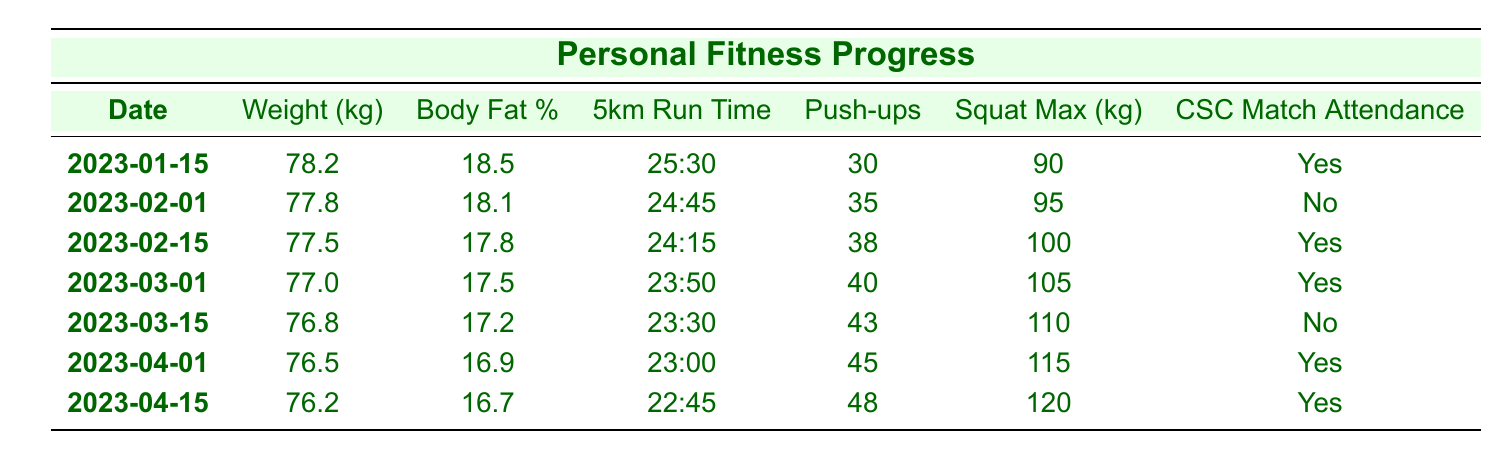What was the lowest recorded weight in the table? The lowest recorded weight can be found by comparing the "Weight (kg)" values across all the rows. The values are 78.2, 77.8, 77.5, 77.0, 76.8, 76.5, and 76.2. The lowest among these is 76.2 kg, which corresponds to the date 2023-04-15.
Answer: 76.2 kg On how many occasions did the attendance for CSC matches occur? To determine the total attendance at CSC matches, count the "Yes" entries in the "CSC Match Attendance" column. There are 5 rows with "Yes" (2023-01-15, 2023-02-15, 2023-03-01, 2023-04-01, and 2023-04-15).
Answer: 5 What is the average body fat percentage from January to April? To find the average body fat percentage, we sum the body fat percentages (18.5, 18.1, 17.8, 17.5, 17.2, and 16.9) and divide by the number of data points (6). The sum is 106.0. Therefore, the average is 106.0/6 ≈ 17.67%.
Answer: 17.67% Did body fat percentage decrease over time? Comparing the body fat percentages from each date shows a consistent decrease: 18.5, 18.1, 17.8, 17.5, 17.2, and 16.9. Since all values decrease over time, we conclude that yes, body fat percentage decreased over the period.
Answer: Yes What is the relationship between push-ups and squat max on March 1? On March 1, the number of push-ups is 40, and the squat max is 105 kg. This suggests a positive relationship since both values indicate improved strength performance. However, this is anecdotal without specific metrics to compare.
Answer: 40 push-ups and 105 kg squat max How many push-ups did the player perform in total from January to April? To find the total push-ups, we sum the push-up values from each relevant date: 30 (Jan) + 35 (Feb 1) + 38 (Feb 15) + 40 (Mar 1) + 43 (Mar 15) + 45 (Apr 1) + 48 (Apr 15) = 339.
Answer: 339 What was the improvement in the 5km run time from January 15 to April 15? The initial run time on January 15 is 25:30 and the final run time on April 15 is 22:45. To find the improvement, convert both to seconds: 25 min 30 sec = 1530 sec and 22 min 45 sec = 1365 sec. The improvement is 1530 – 1365 = 165 seconds, or 2 minutes and 45 seconds.
Answer: 2 minutes 45 seconds In which month did the player have the highest squat max? Looking through the "Squat Max (kg)" values provided, the values are: 90 (January), 95 (February 1), 100 (February 15), 105 (March 1), 110 (March 15), 115 (April 1), and 120 (April 15). The highest is 120 kg from April 15. Therefore, the highest occurred in April.
Answer: April 